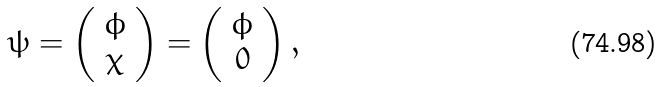<formula> <loc_0><loc_0><loc_500><loc_500>\psi = \left ( \begin{array} { c } \phi \\ \chi \end{array} \right ) = \left ( \begin{array} { c } \phi \\ 0 \end{array} \right ) ,</formula> 